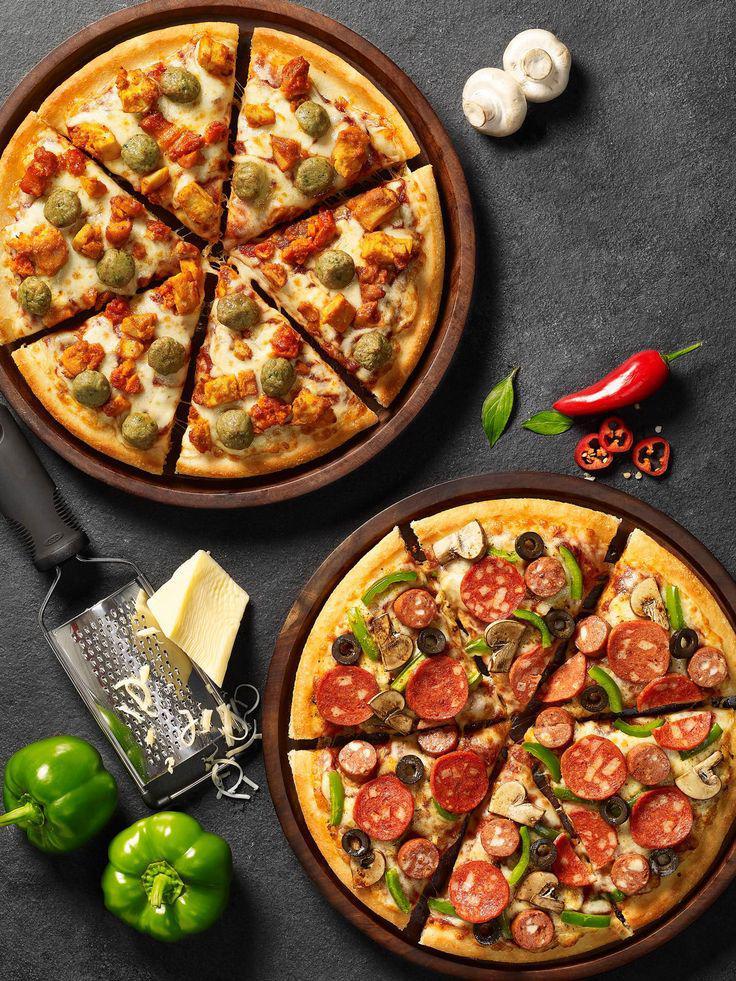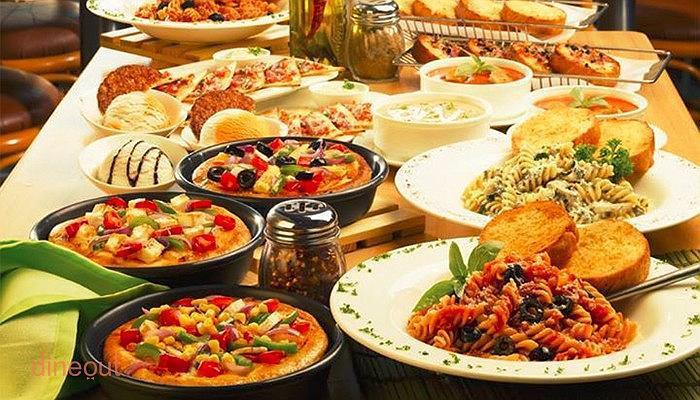The first image is the image on the left, the second image is the image on the right. Assess this claim about the two images: "There are exactly two pizzas.". Correct or not? Answer yes or no. No. The first image is the image on the left, the second image is the image on the right. Examine the images to the left and right. Is the description "There are no more than 2 pizzas." accurate? Answer yes or no. No. 